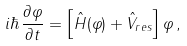<formula> <loc_0><loc_0><loc_500><loc_500>i \hbar { \, } \frac { \partial \varphi } { \partial t } = \left [ \hat { H } ( \varphi ) + \hat { V } _ { r e s } \right ] \varphi \, ,</formula> 